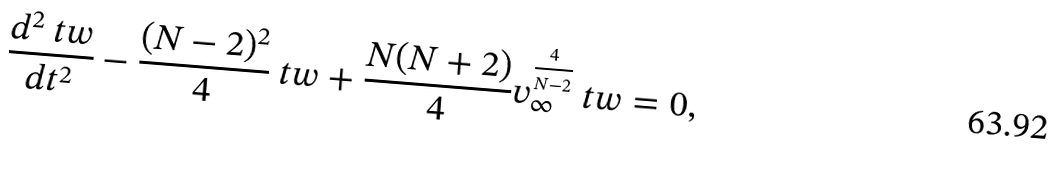<formula> <loc_0><loc_0><loc_500><loc_500>\frac { d ^ { 2 } { \ t w } } { d t ^ { 2 } } - \frac { ( N - 2 ) ^ { 2 } } { 4 } { \ t w } + \frac { N ( N + 2 ) } { 4 } v _ { \infty } ^ { \frac { 4 } { N - 2 } } { \ t w } = 0 ,</formula> 